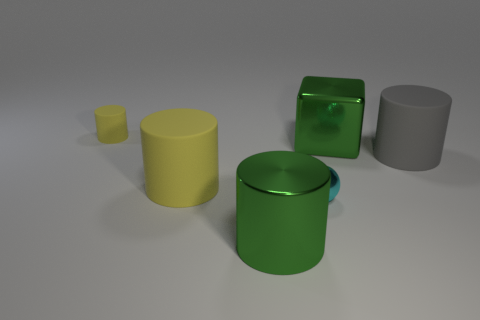Subtract all tiny yellow cylinders. How many cylinders are left? 3 Subtract all yellow balls. How many yellow cylinders are left? 2 Subtract 1 spheres. How many spheres are left? 0 Add 1 big matte objects. How many objects exist? 7 Subtract all gray cylinders. How many cylinders are left? 3 Subtract all blocks. How many objects are left? 5 Add 2 big purple shiny balls. How many big purple shiny balls exist? 2 Subtract 0 red blocks. How many objects are left? 6 Subtract all brown spheres. Subtract all green cylinders. How many spheres are left? 1 Subtract all rubber cylinders. Subtract all small yellow rubber objects. How many objects are left? 2 